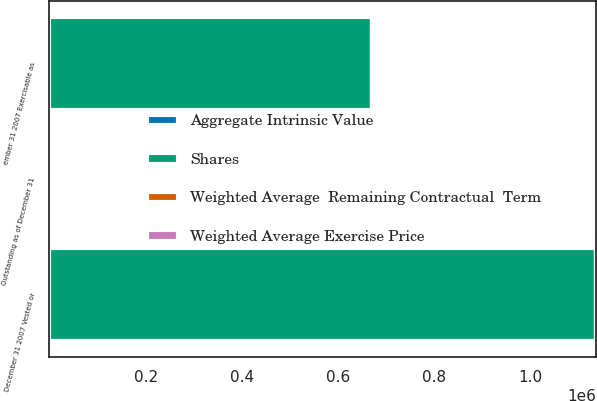Convert chart. <chart><loc_0><loc_0><loc_500><loc_500><stacked_bar_chart><ecel><fcel>Outstanding as of December 31<fcel>December 31 2007 Vested or<fcel>ember 31 2007 Exercisable as<nl><fcel>Shares<fcel>10<fcel>1.13609e+06<fcel>670561<nl><fcel>Weighted Average  Remaining Contractual  Term<fcel>49.42<fcel>49.39<fcel>48.15<nl><fcel>Aggregate Intrinsic Value<fcel>4.93<fcel>5.03<fcel>4.28<nl><fcel>Weighted Average Exercise Price<fcel>10<fcel>10<fcel>7<nl></chart> 